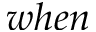Convert formula to latex. <formula><loc_0><loc_0><loc_500><loc_500>w h e n</formula> 